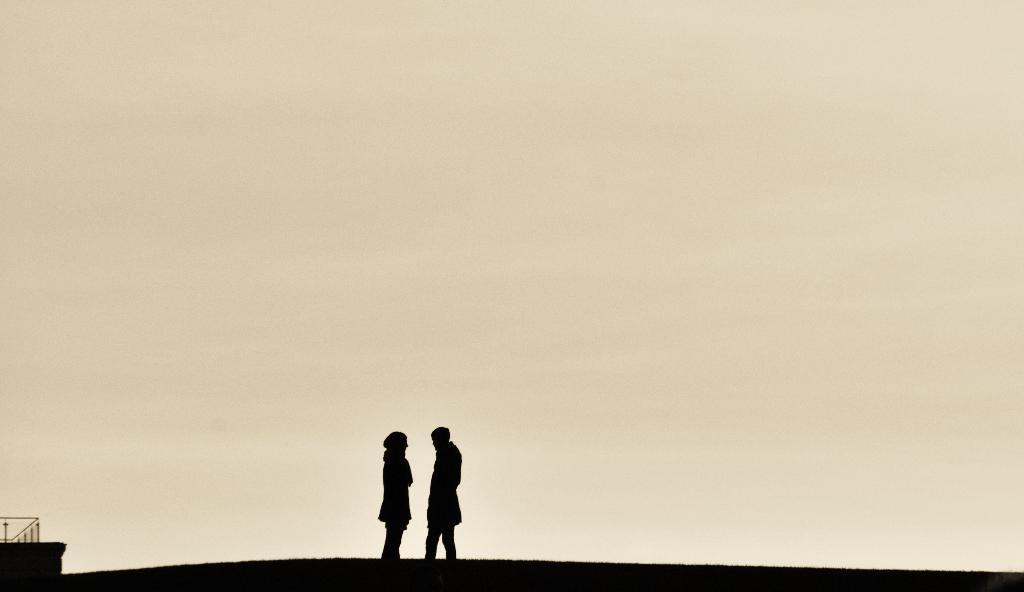Describe this image in one or two sentences. In this image, we can see depiction of persons on the yellow background. 